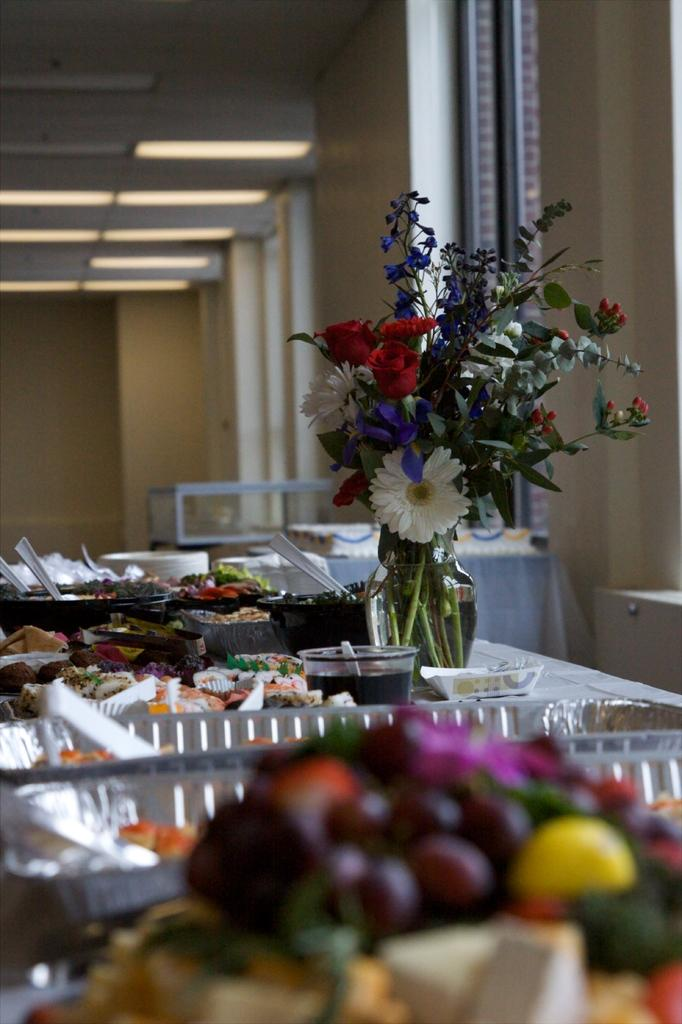What is the main object in the center of the image? There is a table in the center of the image. What is placed on the table? There are food items and a flower vase on the table. Are there any fruits visible on the table? Yes, there are fruits on the table. What can be seen in the background of the image? There is a wall visible in the background of the image. How many beds are visible in the image? There are no beds present in the image. Is there a lock on the flower vase in the image? There is no lock visible on the flower vase in the image. 